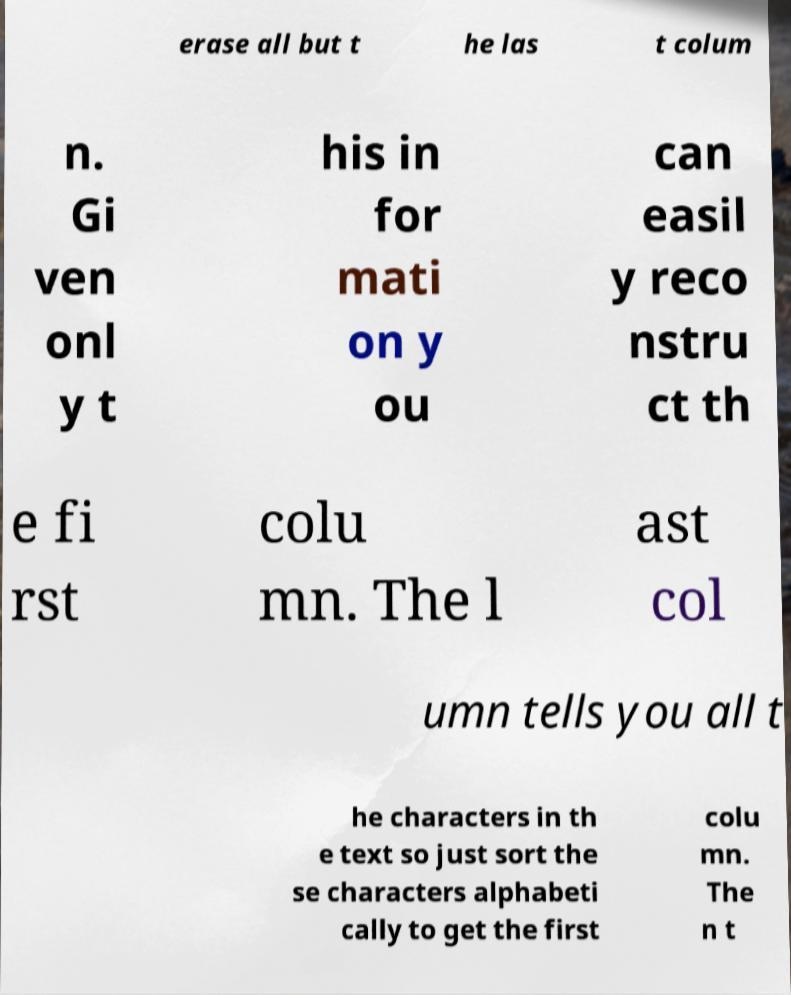Could you assist in decoding the text presented in this image and type it out clearly? erase all but t he las t colum n. Gi ven onl y t his in for mati on y ou can easil y reco nstru ct th e fi rst colu mn. The l ast col umn tells you all t he characters in th e text so just sort the se characters alphabeti cally to get the first colu mn. The n t 